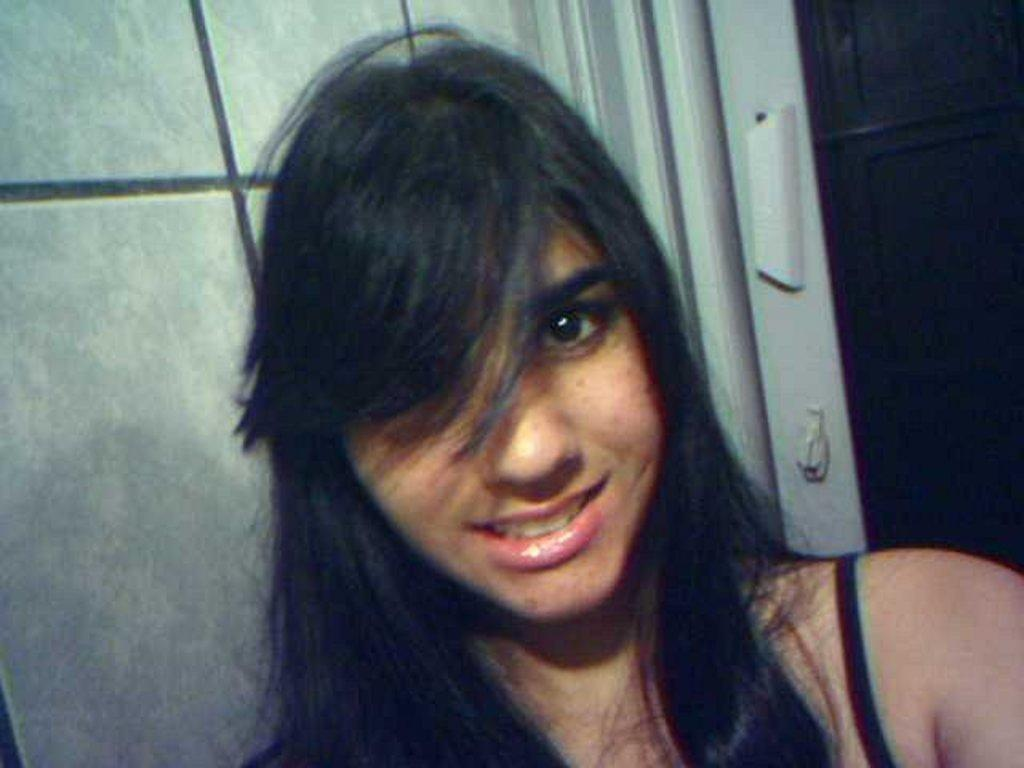Who or what is present in the image? There is a person in the image. What can be seen in the background of the image? There is a door in the background of the image. What color is the wall in the background? The wall in the background is gray. What type of whistle can be heard in the image? There is no whistle present in the image, and therefore no sound can be heard. 